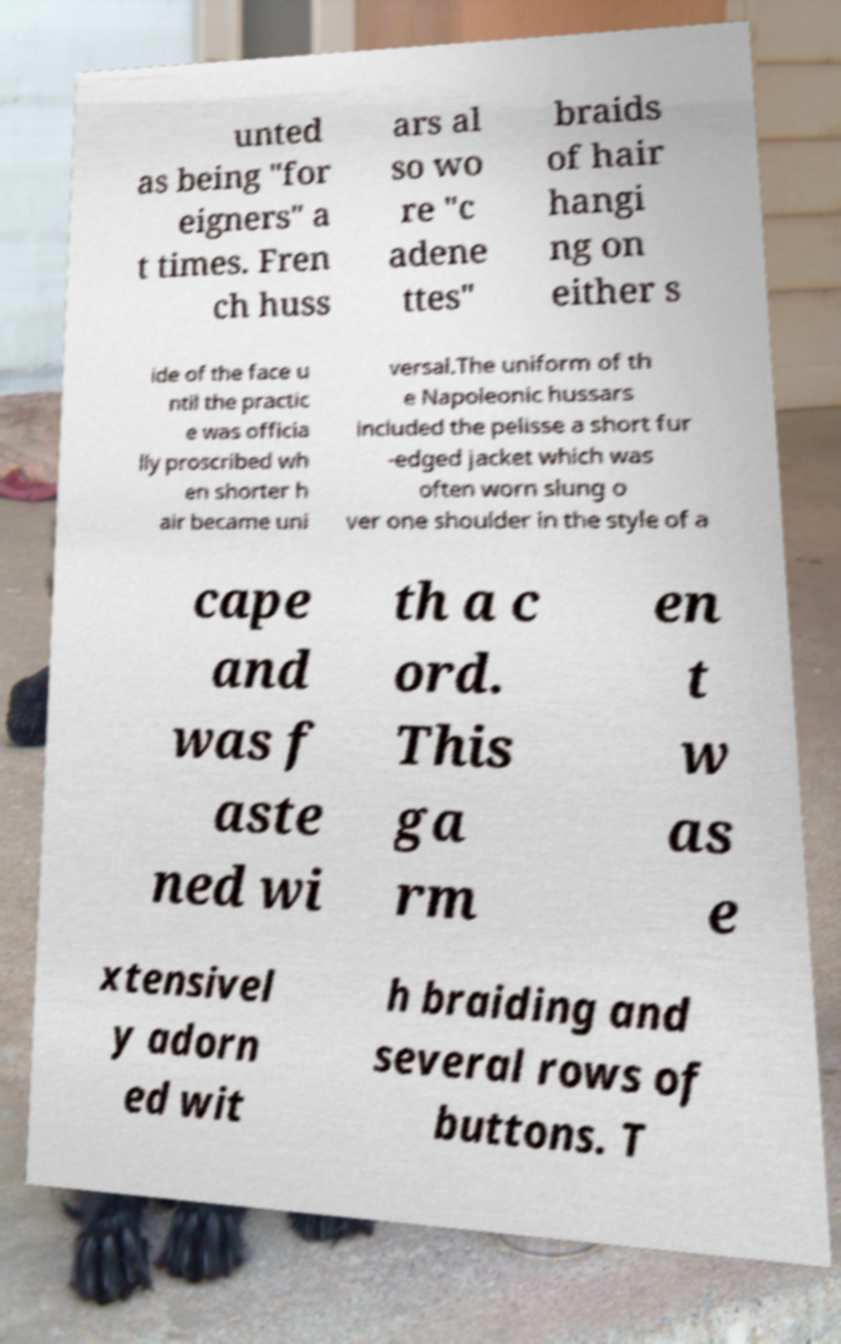Could you extract and type out the text from this image? unted as being "for eigners" a t times. Fren ch huss ars al so wo re "c adene ttes" braids of hair hangi ng on either s ide of the face u ntil the practic e was officia lly proscribed wh en shorter h air became uni versal.The uniform of th e Napoleonic hussars included the pelisse a short fur -edged jacket which was often worn slung o ver one shoulder in the style of a cape and was f aste ned wi th a c ord. This ga rm en t w as e xtensivel y adorn ed wit h braiding and several rows of buttons. T 